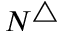<formula> <loc_0><loc_0><loc_500><loc_500>N ^ { \triangle }</formula> 